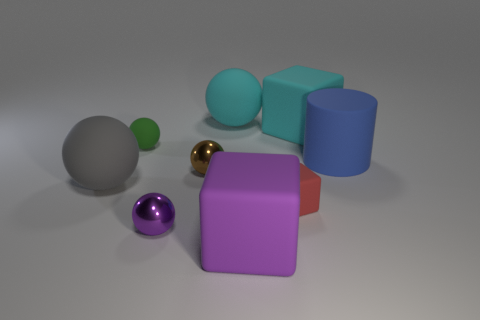Do the block that is behind the gray sphere and the red matte block that is on the right side of the green rubber thing have the same size?
Offer a very short reply. No. What number of blocks are big gray rubber objects or blue matte things?
Your answer should be very brief. 0. How many matte things are large cyan spheres or balls?
Your answer should be compact. 3. What size is the purple thing that is the same shape as the small brown thing?
Ensure brevity in your answer.  Small. Is the size of the blue thing the same as the purple object that is right of the big cyan rubber sphere?
Your answer should be compact. Yes. There is a tiny rubber object that is in front of the small green ball; what shape is it?
Make the answer very short. Cube. What color is the large rubber thing behind the large matte cube that is behind the large rubber cylinder?
Make the answer very short. Cyan. What is the color of the other tiny shiny object that is the same shape as the tiny purple metallic object?
Your response must be concise. Brown. There is a object that is in front of the big gray rubber ball and behind the small purple shiny ball; what is its shape?
Provide a short and direct response. Cube. What is the material of the small object in front of the red object that is to the right of the metal sphere that is to the left of the small brown thing?
Make the answer very short. Metal. 